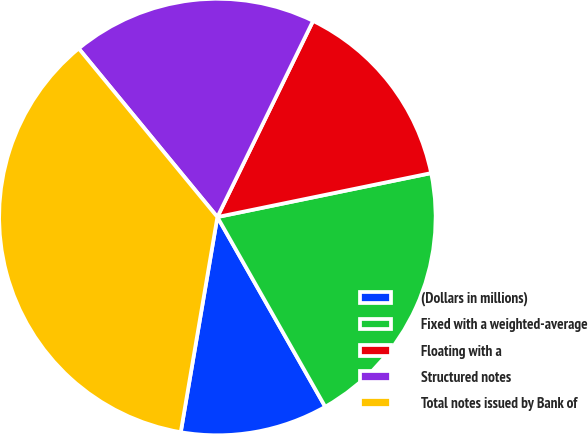Convert chart. <chart><loc_0><loc_0><loc_500><loc_500><pie_chart><fcel>(Dollars in millions)<fcel>Fixed with a weighted-average<fcel>Floating with a<fcel>Structured notes<fcel>Total notes issued by Bank of<nl><fcel>10.91%<fcel>20.0%<fcel>14.55%<fcel>18.18%<fcel>36.36%<nl></chart> 